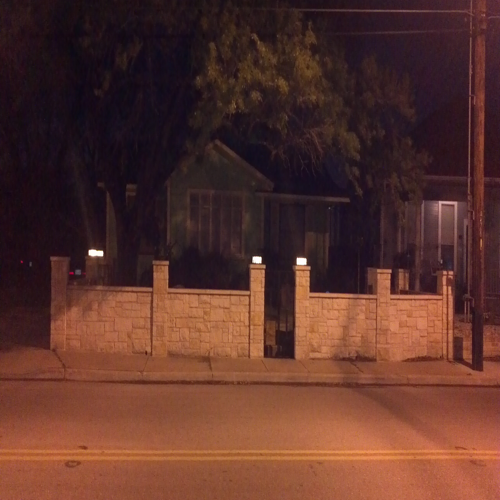Is there any motion blur in the photo?
 No 